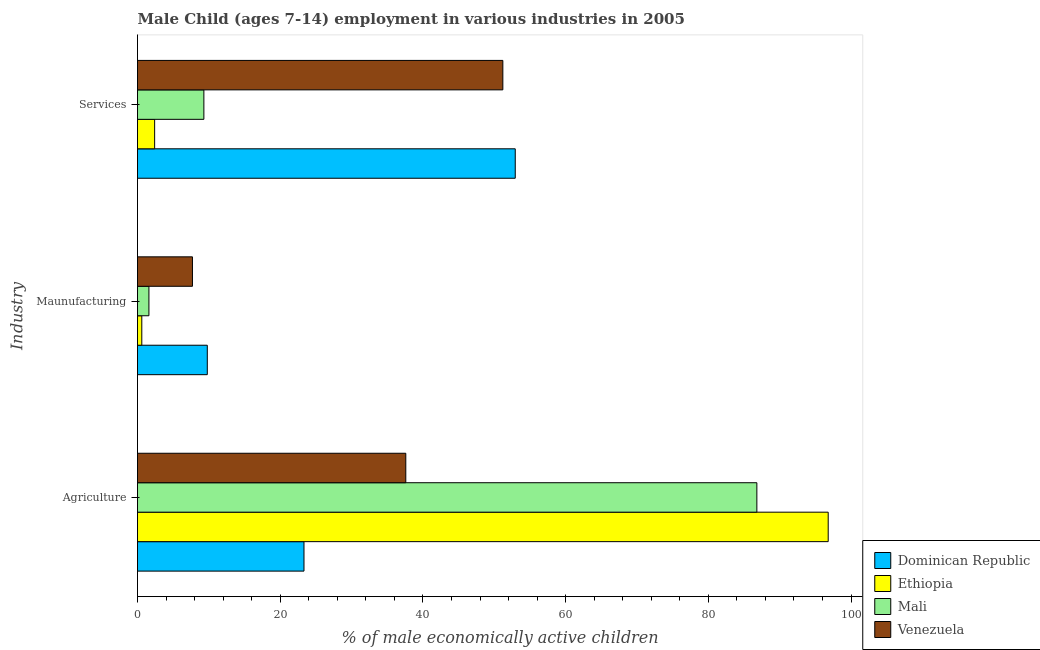How many different coloured bars are there?
Your answer should be very brief. 4. How many bars are there on the 3rd tick from the bottom?
Offer a terse response. 4. What is the label of the 2nd group of bars from the top?
Give a very brief answer. Maunufacturing. What is the percentage of economically active children in agriculture in Venezuela?
Provide a short and direct response. 37.6. Across all countries, what is the maximum percentage of economically active children in manufacturing?
Offer a very short reply. 9.78. Across all countries, what is the minimum percentage of economically active children in agriculture?
Give a very brief answer. 23.33. In which country was the percentage of economically active children in services maximum?
Ensure brevity in your answer.  Dominican Republic. In which country was the percentage of economically active children in services minimum?
Keep it short and to the point. Ethiopia. What is the total percentage of economically active children in agriculture in the graph?
Provide a succinct answer. 244.53. What is the difference between the percentage of economically active children in agriculture in Mali and that in Venezuela?
Offer a very short reply. 49.2. What is the difference between the percentage of economically active children in agriculture in Dominican Republic and the percentage of economically active children in manufacturing in Venezuela?
Provide a succinct answer. 15.63. What is the average percentage of economically active children in agriculture per country?
Make the answer very short. 61.13. What is the difference between the percentage of economically active children in services and percentage of economically active children in agriculture in Venezuela?
Provide a short and direct response. 13.6. What is the ratio of the percentage of economically active children in agriculture in Mali to that in Dominican Republic?
Provide a succinct answer. 3.72. Is the percentage of economically active children in services in Venezuela less than that in Ethiopia?
Your answer should be very brief. No. What is the difference between the highest and the lowest percentage of economically active children in services?
Your answer should be very brief. 50.54. In how many countries, is the percentage of economically active children in agriculture greater than the average percentage of economically active children in agriculture taken over all countries?
Your answer should be compact. 2. What does the 1st bar from the top in Maunufacturing represents?
Offer a terse response. Venezuela. What does the 4th bar from the bottom in Services represents?
Make the answer very short. Venezuela. How many bars are there?
Give a very brief answer. 12. How many countries are there in the graph?
Keep it short and to the point. 4. What is the difference between two consecutive major ticks on the X-axis?
Offer a very short reply. 20. Are the values on the major ticks of X-axis written in scientific E-notation?
Provide a short and direct response. No. Does the graph contain any zero values?
Keep it short and to the point. No. Where does the legend appear in the graph?
Your answer should be compact. Bottom right. How many legend labels are there?
Your answer should be very brief. 4. How are the legend labels stacked?
Offer a very short reply. Vertical. What is the title of the graph?
Ensure brevity in your answer.  Male Child (ages 7-14) employment in various industries in 2005. Does "Bulgaria" appear as one of the legend labels in the graph?
Your answer should be compact. No. What is the label or title of the X-axis?
Ensure brevity in your answer.  % of male economically active children. What is the label or title of the Y-axis?
Offer a very short reply. Industry. What is the % of male economically active children of Dominican Republic in Agriculture?
Provide a succinct answer. 23.33. What is the % of male economically active children of Ethiopia in Agriculture?
Offer a very short reply. 96.8. What is the % of male economically active children of Mali in Agriculture?
Provide a short and direct response. 86.8. What is the % of male economically active children in Venezuela in Agriculture?
Provide a succinct answer. 37.6. What is the % of male economically active children in Dominican Republic in Maunufacturing?
Your answer should be very brief. 9.78. What is the % of male economically active children in Ethiopia in Maunufacturing?
Offer a terse response. 0.6. What is the % of male economically active children of Mali in Maunufacturing?
Your answer should be compact. 1.6. What is the % of male economically active children in Dominican Republic in Services?
Your answer should be very brief. 52.94. What is the % of male economically active children in Ethiopia in Services?
Provide a short and direct response. 2.4. What is the % of male economically active children of Mali in Services?
Offer a terse response. 9.3. What is the % of male economically active children of Venezuela in Services?
Your answer should be compact. 51.2. Across all Industry, what is the maximum % of male economically active children of Dominican Republic?
Provide a succinct answer. 52.94. Across all Industry, what is the maximum % of male economically active children of Ethiopia?
Ensure brevity in your answer.  96.8. Across all Industry, what is the maximum % of male economically active children of Mali?
Offer a very short reply. 86.8. Across all Industry, what is the maximum % of male economically active children in Venezuela?
Your response must be concise. 51.2. Across all Industry, what is the minimum % of male economically active children of Dominican Republic?
Your answer should be very brief. 9.78. Across all Industry, what is the minimum % of male economically active children in Ethiopia?
Make the answer very short. 0.6. Across all Industry, what is the minimum % of male economically active children in Venezuela?
Make the answer very short. 7.7. What is the total % of male economically active children of Dominican Republic in the graph?
Offer a terse response. 86.05. What is the total % of male economically active children of Ethiopia in the graph?
Make the answer very short. 99.8. What is the total % of male economically active children of Mali in the graph?
Make the answer very short. 97.7. What is the total % of male economically active children of Venezuela in the graph?
Your answer should be very brief. 96.5. What is the difference between the % of male economically active children in Dominican Republic in Agriculture and that in Maunufacturing?
Offer a terse response. 13.55. What is the difference between the % of male economically active children of Ethiopia in Agriculture and that in Maunufacturing?
Provide a short and direct response. 96.2. What is the difference between the % of male economically active children in Mali in Agriculture and that in Maunufacturing?
Make the answer very short. 85.2. What is the difference between the % of male economically active children in Venezuela in Agriculture and that in Maunufacturing?
Offer a very short reply. 29.9. What is the difference between the % of male economically active children of Dominican Republic in Agriculture and that in Services?
Ensure brevity in your answer.  -29.61. What is the difference between the % of male economically active children of Ethiopia in Agriculture and that in Services?
Give a very brief answer. 94.4. What is the difference between the % of male economically active children of Mali in Agriculture and that in Services?
Provide a short and direct response. 77.5. What is the difference between the % of male economically active children of Venezuela in Agriculture and that in Services?
Give a very brief answer. -13.6. What is the difference between the % of male economically active children of Dominican Republic in Maunufacturing and that in Services?
Give a very brief answer. -43.16. What is the difference between the % of male economically active children of Mali in Maunufacturing and that in Services?
Ensure brevity in your answer.  -7.7. What is the difference between the % of male economically active children of Venezuela in Maunufacturing and that in Services?
Ensure brevity in your answer.  -43.5. What is the difference between the % of male economically active children in Dominican Republic in Agriculture and the % of male economically active children in Ethiopia in Maunufacturing?
Ensure brevity in your answer.  22.73. What is the difference between the % of male economically active children in Dominican Republic in Agriculture and the % of male economically active children in Mali in Maunufacturing?
Keep it short and to the point. 21.73. What is the difference between the % of male economically active children of Dominican Republic in Agriculture and the % of male economically active children of Venezuela in Maunufacturing?
Your answer should be very brief. 15.63. What is the difference between the % of male economically active children of Ethiopia in Agriculture and the % of male economically active children of Mali in Maunufacturing?
Ensure brevity in your answer.  95.2. What is the difference between the % of male economically active children of Ethiopia in Agriculture and the % of male economically active children of Venezuela in Maunufacturing?
Offer a terse response. 89.1. What is the difference between the % of male economically active children of Mali in Agriculture and the % of male economically active children of Venezuela in Maunufacturing?
Your answer should be compact. 79.1. What is the difference between the % of male economically active children of Dominican Republic in Agriculture and the % of male economically active children of Ethiopia in Services?
Make the answer very short. 20.93. What is the difference between the % of male economically active children in Dominican Republic in Agriculture and the % of male economically active children in Mali in Services?
Ensure brevity in your answer.  14.03. What is the difference between the % of male economically active children in Dominican Republic in Agriculture and the % of male economically active children in Venezuela in Services?
Ensure brevity in your answer.  -27.87. What is the difference between the % of male economically active children of Ethiopia in Agriculture and the % of male economically active children of Mali in Services?
Keep it short and to the point. 87.5. What is the difference between the % of male economically active children of Ethiopia in Agriculture and the % of male economically active children of Venezuela in Services?
Your answer should be compact. 45.6. What is the difference between the % of male economically active children of Mali in Agriculture and the % of male economically active children of Venezuela in Services?
Your answer should be very brief. 35.6. What is the difference between the % of male economically active children of Dominican Republic in Maunufacturing and the % of male economically active children of Ethiopia in Services?
Offer a very short reply. 7.38. What is the difference between the % of male economically active children in Dominican Republic in Maunufacturing and the % of male economically active children in Mali in Services?
Provide a short and direct response. 0.48. What is the difference between the % of male economically active children of Dominican Republic in Maunufacturing and the % of male economically active children of Venezuela in Services?
Provide a succinct answer. -41.42. What is the difference between the % of male economically active children in Ethiopia in Maunufacturing and the % of male economically active children in Mali in Services?
Your answer should be compact. -8.7. What is the difference between the % of male economically active children of Ethiopia in Maunufacturing and the % of male economically active children of Venezuela in Services?
Your answer should be very brief. -50.6. What is the difference between the % of male economically active children of Mali in Maunufacturing and the % of male economically active children of Venezuela in Services?
Your response must be concise. -49.6. What is the average % of male economically active children in Dominican Republic per Industry?
Your answer should be very brief. 28.68. What is the average % of male economically active children in Ethiopia per Industry?
Your response must be concise. 33.27. What is the average % of male economically active children of Mali per Industry?
Make the answer very short. 32.57. What is the average % of male economically active children of Venezuela per Industry?
Provide a short and direct response. 32.17. What is the difference between the % of male economically active children in Dominican Republic and % of male economically active children in Ethiopia in Agriculture?
Ensure brevity in your answer.  -73.47. What is the difference between the % of male economically active children of Dominican Republic and % of male economically active children of Mali in Agriculture?
Give a very brief answer. -63.47. What is the difference between the % of male economically active children in Dominican Republic and % of male economically active children in Venezuela in Agriculture?
Offer a very short reply. -14.27. What is the difference between the % of male economically active children of Ethiopia and % of male economically active children of Mali in Agriculture?
Your response must be concise. 10. What is the difference between the % of male economically active children in Ethiopia and % of male economically active children in Venezuela in Agriculture?
Make the answer very short. 59.2. What is the difference between the % of male economically active children of Mali and % of male economically active children of Venezuela in Agriculture?
Your response must be concise. 49.2. What is the difference between the % of male economically active children in Dominican Republic and % of male economically active children in Ethiopia in Maunufacturing?
Your answer should be compact. 9.18. What is the difference between the % of male economically active children of Dominican Republic and % of male economically active children of Mali in Maunufacturing?
Ensure brevity in your answer.  8.18. What is the difference between the % of male economically active children of Dominican Republic and % of male economically active children of Venezuela in Maunufacturing?
Keep it short and to the point. 2.08. What is the difference between the % of male economically active children in Dominican Republic and % of male economically active children in Ethiopia in Services?
Ensure brevity in your answer.  50.54. What is the difference between the % of male economically active children of Dominican Republic and % of male economically active children of Mali in Services?
Keep it short and to the point. 43.64. What is the difference between the % of male economically active children in Dominican Republic and % of male economically active children in Venezuela in Services?
Provide a short and direct response. 1.74. What is the difference between the % of male economically active children of Ethiopia and % of male economically active children of Venezuela in Services?
Offer a terse response. -48.8. What is the difference between the % of male economically active children in Mali and % of male economically active children in Venezuela in Services?
Provide a succinct answer. -41.9. What is the ratio of the % of male economically active children in Dominican Republic in Agriculture to that in Maunufacturing?
Your answer should be compact. 2.39. What is the ratio of the % of male economically active children of Ethiopia in Agriculture to that in Maunufacturing?
Ensure brevity in your answer.  161.33. What is the ratio of the % of male economically active children of Mali in Agriculture to that in Maunufacturing?
Your answer should be compact. 54.25. What is the ratio of the % of male economically active children in Venezuela in Agriculture to that in Maunufacturing?
Give a very brief answer. 4.88. What is the ratio of the % of male economically active children in Dominican Republic in Agriculture to that in Services?
Offer a very short reply. 0.44. What is the ratio of the % of male economically active children of Ethiopia in Agriculture to that in Services?
Your response must be concise. 40.33. What is the ratio of the % of male economically active children of Mali in Agriculture to that in Services?
Offer a terse response. 9.33. What is the ratio of the % of male economically active children of Venezuela in Agriculture to that in Services?
Ensure brevity in your answer.  0.73. What is the ratio of the % of male economically active children of Dominican Republic in Maunufacturing to that in Services?
Provide a succinct answer. 0.18. What is the ratio of the % of male economically active children in Mali in Maunufacturing to that in Services?
Provide a succinct answer. 0.17. What is the ratio of the % of male economically active children in Venezuela in Maunufacturing to that in Services?
Provide a short and direct response. 0.15. What is the difference between the highest and the second highest % of male economically active children in Dominican Republic?
Keep it short and to the point. 29.61. What is the difference between the highest and the second highest % of male economically active children in Ethiopia?
Offer a very short reply. 94.4. What is the difference between the highest and the second highest % of male economically active children in Mali?
Offer a very short reply. 77.5. What is the difference between the highest and the lowest % of male economically active children of Dominican Republic?
Offer a very short reply. 43.16. What is the difference between the highest and the lowest % of male economically active children of Ethiopia?
Offer a very short reply. 96.2. What is the difference between the highest and the lowest % of male economically active children in Mali?
Provide a succinct answer. 85.2. What is the difference between the highest and the lowest % of male economically active children in Venezuela?
Offer a terse response. 43.5. 